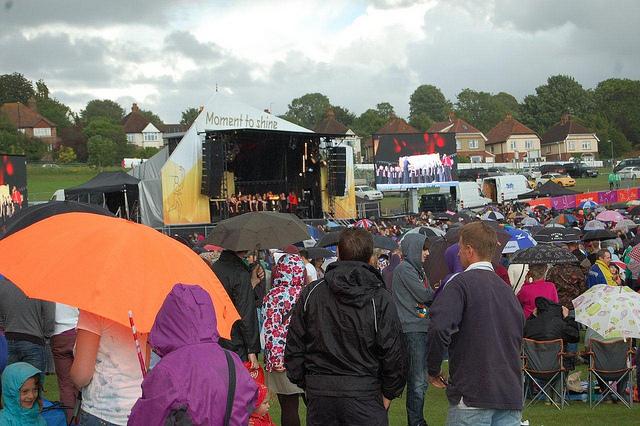What general activity are these peoples engaged in doing?
Short answer required. Watching show. How many people are in the crowd?
Keep it brief. 50. Are the umbrellas multicolored?
Answer briefly. Yes. What color is the bright umbrella?
Give a very brief answer. Orange. How many houses are in the background?
Answer briefly. 6. How many black umbrellas?
Answer briefly. 5. Is the person without an umbrella a man?
Write a very short answer. Yes. 